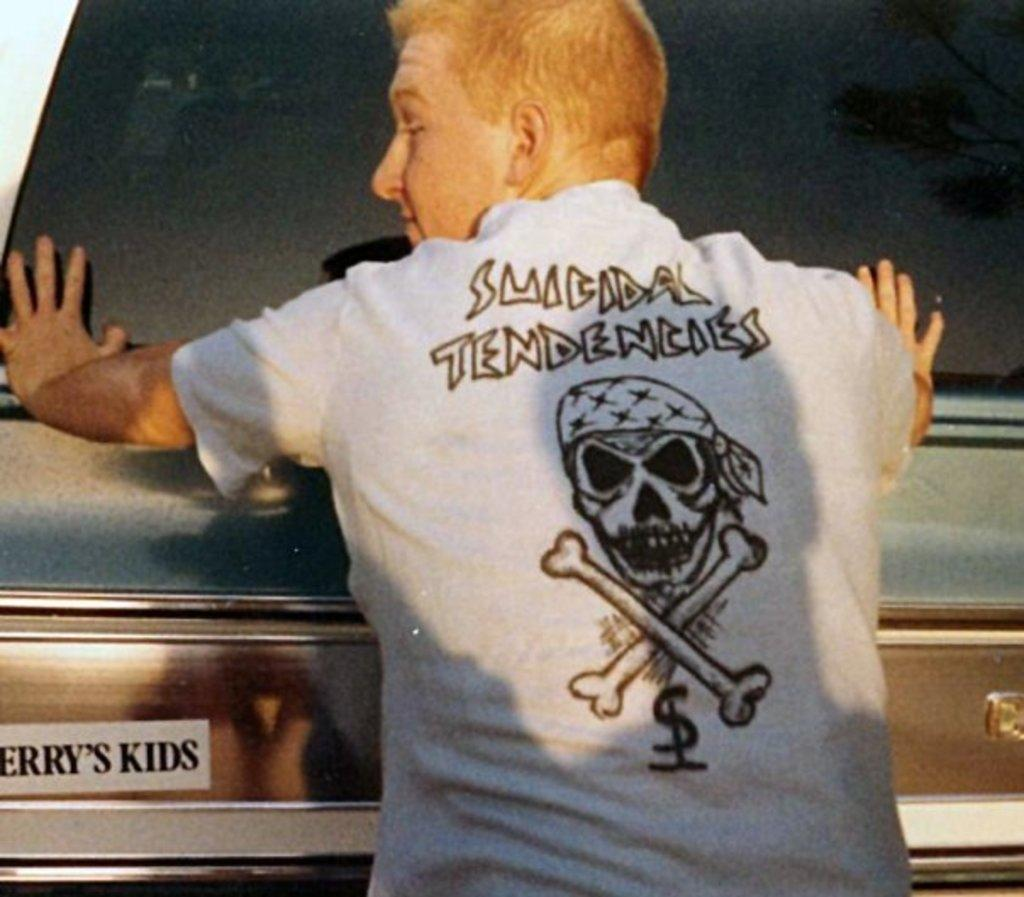Who is present in the image? There is a man in the image. What is the man wearing? The man is wearing a white t-shirt. What can be seen on the man's t-shirt? There is text on the man's t-shirt. What is visible in the background of the image? There appears to be a vehicle in the background of the image. What can be seen on the vehicle? There is text on the vehicle. How many clover leaves can be seen on the man's t-shirt? There are no clover leaves visible on the man's t-shirt; it features text instead. What type of step is the man taking in the image? There is no indication of the man taking a step in the image; he is standing still. 